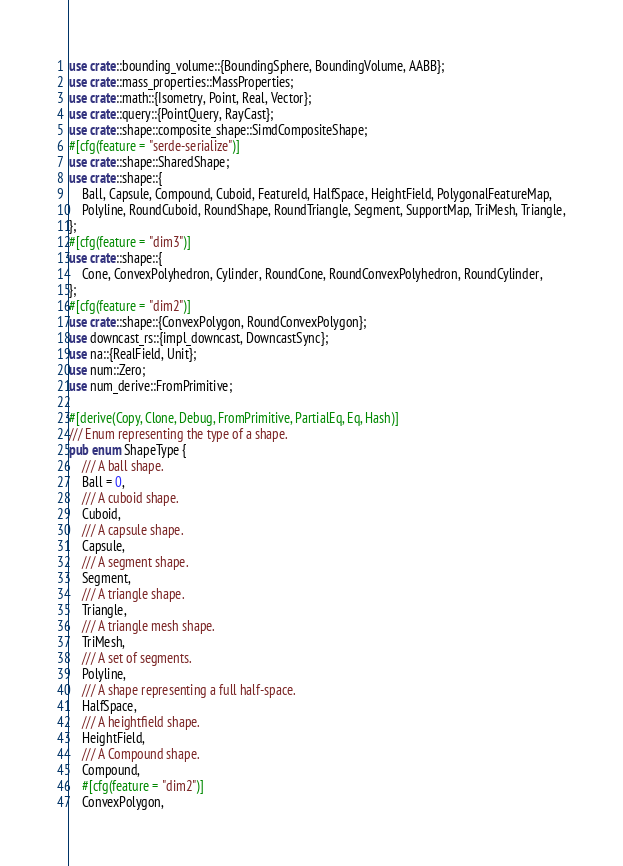<code> <loc_0><loc_0><loc_500><loc_500><_Rust_>use crate::bounding_volume::{BoundingSphere, BoundingVolume, AABB};
use crate::mass_properties::MassProperties;
use crate::math::{Isometry, Point, Real, Vector};
use crate::query::{PointQuery, RayCast};
use crate::shape::composite_shape::SimdCompositeShape;
#[cfg(feature = "serde-serialize")]
use crate::shape::SharedShape;
use crate::shape::{
    Ball, Capsule, Compound, Cuboid, FeatureId, HalfSpace, HeightField, PolygonalFeatureMap,
    Polyline, RoundCuboid, RoundShape, RoundTriangle, Segment, SupportMap, TriMesh, Triangle,
};
#[cfg(feature = "dim3")]
use crate::shape::{
    Cone, ConvexPolyhedron, Cylinder, RoundCone, RoundConvexPolyhedron, RoundCylinder,
};
#[cfg(feature = "dim2")]
use crate::shape::{ConvexPolygon, RoundConvexPolygon};
use downcast_rs::{impl_downcast, DowncastSync};
use na::{RealField, Unit};
use num::Zero;
use num_derive::FromPrimitive;

#[derive(Copy, Clone, Debug, FromPrimitive, PartialEq, Eq, Hash)]
/// Enum representing the type of a shape.
pub enum ShapeType {
    /// A ball shape.
    Ball = 0,
    /// A cuboid shape.
    Cuboid,
    /// A capsule shape.
    Capsule,
    /// A segment shape.
    Segment,
    /// A triangle shape.
    Triangle,
    /// A triangle mesh shape.
    TriMesh,
    /// A set of segments.
    Polyline,
    /// A shape representing a full half-space.
    HalfSpace,
    /// A heightfield shape.
    HeightField,
    /// A Compound shape.
    Compound,
    #[cfg(feature = "dim2")]
    ConvexPolygon,</code> 